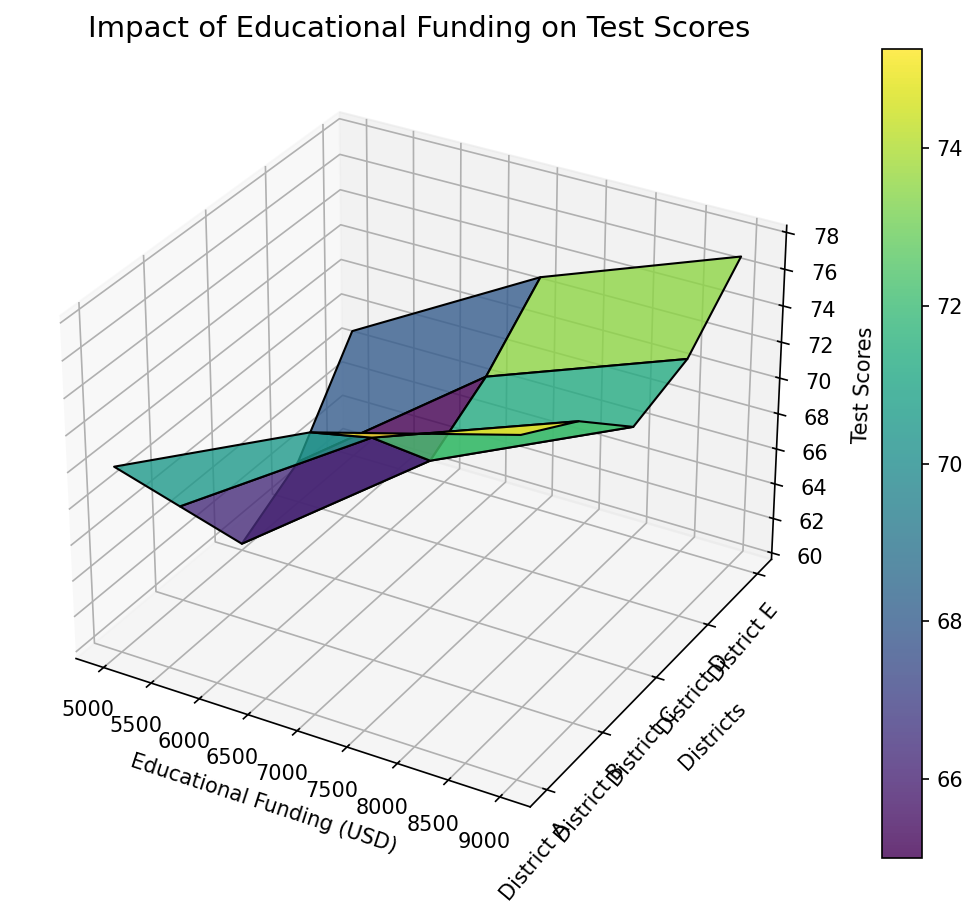Which district shows the highest test score for $9000 in educational funding? By observing the surface at the educational funding level of $9000, the highest point on the Z-axis corresponds to the district with the highest test score.
Answer: District A Among District C and District D, which one shows a higher test score for $7000 in educational funding? Comparing the heights on the Z-axis for Districts C and D at $7000 funding, the test score for District D (70) is higher than that for District C (68).
Answer: District D What is the difference in test scores for District A between $9000 and $5000 in educational funding? The test score for District A at $9000 is 78 and at $5000 is 70. The difference is 78 - 70.
Answer: 8 Which district shows the largest improvement in test scores when comparing $5000 to $7000 in educational funding? By observing the changes in heights from $5000 to $7000 for each district, District C shows an increase from 60 to 68, which is the largest improvement among all the districts
Answer: District C What is the average test score for District B across all funding levels? Sum the test scores for District B across funding levels: 65 + 72 + 76, and then divide by 3. The average is (65 + 72 + 76) / 3.
Answer: 71 Is there any district where the test scores decrease as the funding increases from $5000 to $9000? By observing the surface plot, all districts show an increase in test scores as the funding increases from $5000 to $9000.
Answer: No What is the test score range (difference between highest and lowest test scores) for District E across the funding levels? Identify the highest (77) and lowest (67) test scores for District E and calculate the difference, which is 77 - 67.
Answer: 10 